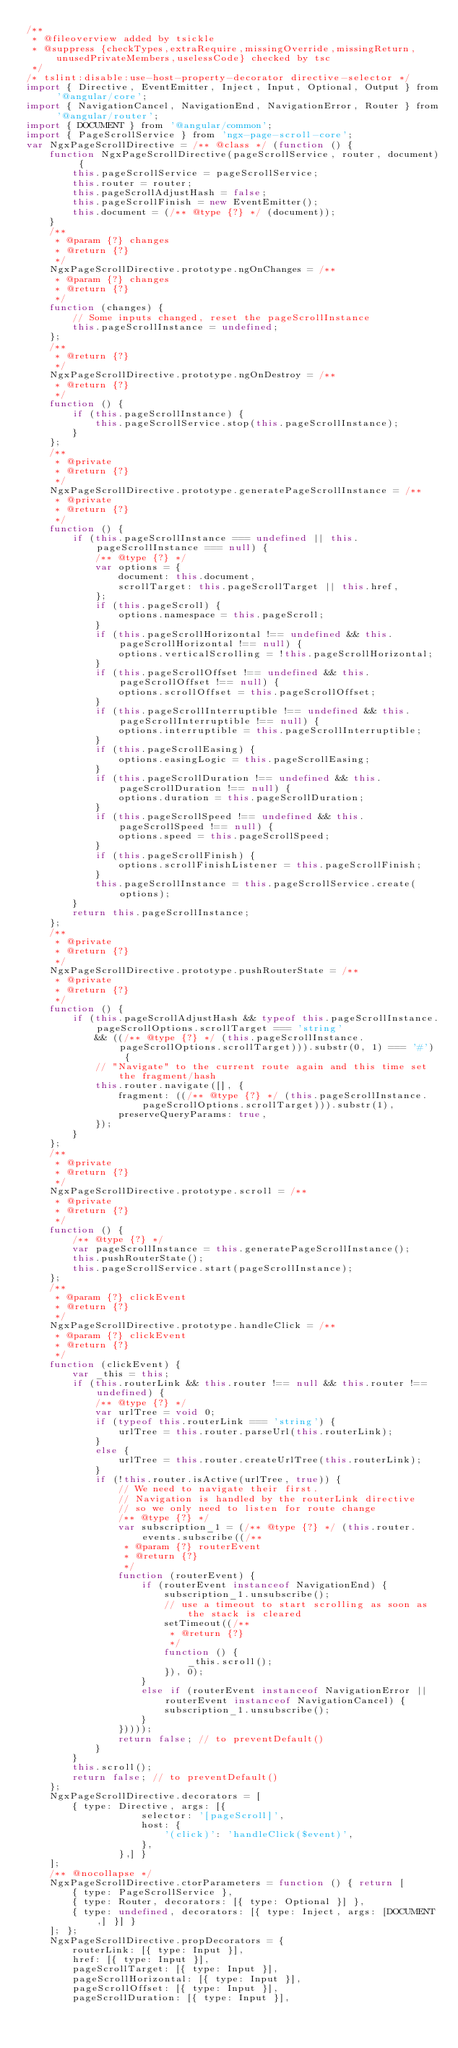<code> <loc_0><loc_0><loc_500><loc_500><_JavaScript_>/**
 * @fileoverview added by tsickle
 * @suppress {checkTypes,extraRequire,missingOverride,missingReturn,unusedPrivateMembers,uselessCode} checked by tsc
 */
/* tslint:disable:use-host-property-decorator directive-selector */
import { Directive, EventEmitter, Inject, Input, Optional, Output } from '@angular/core';
import { NavigationCancel, NavigationEnd, NavigationError, Router } from '@angular/router';
import { DOCUMENT } from '@angular/common';
import { PageScrollService } from 'ngx-page-scroll-core';
var NgxPageScrollDirective = /** @class */ (function () {
    function NgxPageScrollDirective(pageScrollService, router, document) {
        this.pageScrollService = pageScrollService;
        this.router = router;
        this.pageScrollAdjustHash = false;
        this.pageScrollFinish = new EventEmitter();
        this.document = (/** @type {?} */ (document));
    }
    /**
     * @param {?} changes
     * @return {?}
     */
    NgxPageScrollDirective.prototype.ngOnChanges = /**
     * @param {?} changes
     * @return {?}
     */
    function (changes) {
        // Some inputs changed, reset the pageScrollInstance
        this.pageScrollInstance = undefined;
    };
    /**
     * @return {?}
     */
    NgxPageScrollDirective.prototype.ngOnDestroy = /**
     * @return {?}
     */
    function () {
        if (this.pageScrollInstance) {
            this.pageScrollService.stop(this.pageScrollInstance);
        }
    };
    /**
     * @private
     * @return {?}
     */
    NgxPageScrollDirective.prototype.generatePageScrollInstance = /**
     * @private
     * @return {?}
     */
    function () {
        if (this.pageScrollInstance === undefined || this.pageScrollInstance === null) {
            /** @type {?} */
            var options = {
                document: this.document,
                scrollTarget: this.pageScrollTarget || this.href,
            };
            if (this.pageScroll) {
                options.namespace = this.pageScroll;
            }
            if (this.pageScrollHorizontal !== undefined && this.pageScrollHorizontal !== null) {
                options.verticalScrolling = !this.pageScrollHorizontal;
            }
            if (this.pageScrollOffset !== undefined && this.pageScrollOffset !== null) {
                options.scrollOffset = this.pageScrollOffset;
            }
            if (this.pageScrollInterruptible !== undefined && this.pageScrollInterruptible !== null) {
                options.interruptible = this.pageScrollInterruptible;
            }
            if (this.pageScrollEasing) {
                options.easingLogic = this.pageScrollEasing;
            }
            if (this.pageScrollDuration !== undefined && this.pageScrollDuration !== null) {
                options.duration = this.pageScrollDuration;
            }
            if (this.pageScrollSpeed !== undefined && this.pageScrollSpeed !== null) {
                options.speed = this.pageScrollSpeed;
            }
            if (this.pageScrollFinish) {
                options.scrollFinishListener = this.pageScrollFinish;
            }
            this.pageScrollInstance = this.pageScrollService.create(options);
        }
        return this.pageScrollInstance;
    };
    /**
     * @private
     * @return {?}
     */
    NgxPageScrollDirective.prototype.pushRouterState = /**
     * @private
     * @return {?}
     */
    function () {
        if (this.pageScrollAdjustHash && typeof this.pageScrollInstance.pageScrollOptions.scrollTarget === 'string'
            && ((/** @type {?} */ (this.pageScrollInstance.pageScrollOptions.scrollTarget))).substr(0, 1) === '#') {
            // "Navigate" to the current route again and this time set the fragment/hash
            this.router.navigate([], {
                fragment: ((/** @type {?} */ (this.pageScrollInstance.pageScrollOptions.scrollTarget))).substr(1),
                preserveQueryParams: true,
            });
        }
    };
    /**
     * @private
     * @return {?}
     */
    NgxPageScrollDirective.prototype.scroll = /**
     * @private
     * @return {?}
     */
    function () {
        /** @type {?} */
        var pageScrollInstance = this.generatePageScrollInstance();
        this.pushRouterState();
        this.pageScrollService.start(pageScrollInstance);
    };
    /**
     * @param {?} clickEvent
     * @return {?}
     */
    NgxPageScrollDirective.prototype.handleClick = /**
     * @param {?} clickEvent
     * @return {?}
     */
    function (clickEvent) {
        var _this = this;
        if (this.routerLink && this.router !== null && this.router !== undefined) {
            /** @type {?} */
            var urlTree = void 0;
            if (typeof this.routerLink === 'string') {
                urlTree = this.router.parseUrl(this.routerLink);
            }
            else {
                urlTree = this.router.createUrlTree(this.routerLink);
            }
            if (!this.router.isActive(urlTree, true)) {
                // We need to navigate their first.
                // Navigation is handled by the routerLink directive
                // so we only need to listen for route change
                /** @type {?} */
                var subscription_1 = (/** @type {?} */ (this.router.events.subscribe((/**
                 * @param {?} routerEvent
                 * @return {?}
                 */
                function (routerEvent) {
                    if (routerEvent instanceof NavigationEnd) {
                        subscription_1.unsubscribe();
                        // use a timeout to start scrolling as soon as the stack is cleared
                        setTimeout((/**
                         * @return {?}
                         */
                        function () {
                            _this.scroll();
                        }), 0);
                    }
                    else if (routerEvent instanceof NavigationError || routerEvent instanceof NavigationCancel) {
                        subscription_1.unsubscribe();
                    }
                }))));
                return false; // to preventDefault()
            }
        }
        this.scroll();
        return false; // to preventDefault()
    };
    NgxPageScrollDirective.decorators = [
        { type: Directive, args: [{
                    selector: '[pageScroll]',
                    host: {
                        '(click)': 'handleClick($event)',
                    },
                },] }
    ];
    /** @nocollapse */
    NgxPageScrollDirective.ctorParameters = function () { return [
        { type: PageScrollService },
        { type: Router, decorators: [{ type: Optional }] },
        { type: undefined, decorators: [{ type: Inject, args: [DOCUMENT,] }] }
    ]; };
    NgxPageScrollDirective.propDecorators = {
        routerLink: [{ type: Input }],
        href: [{ type: Input }],
        pageScrollTarget: [{ type: Input }],
        pageScrollHorizontal: [{ type: Input }],
        pageScrollOffset: [{ type: Input }],
        pageScrollDuration: [{ type: Input }],</code> 